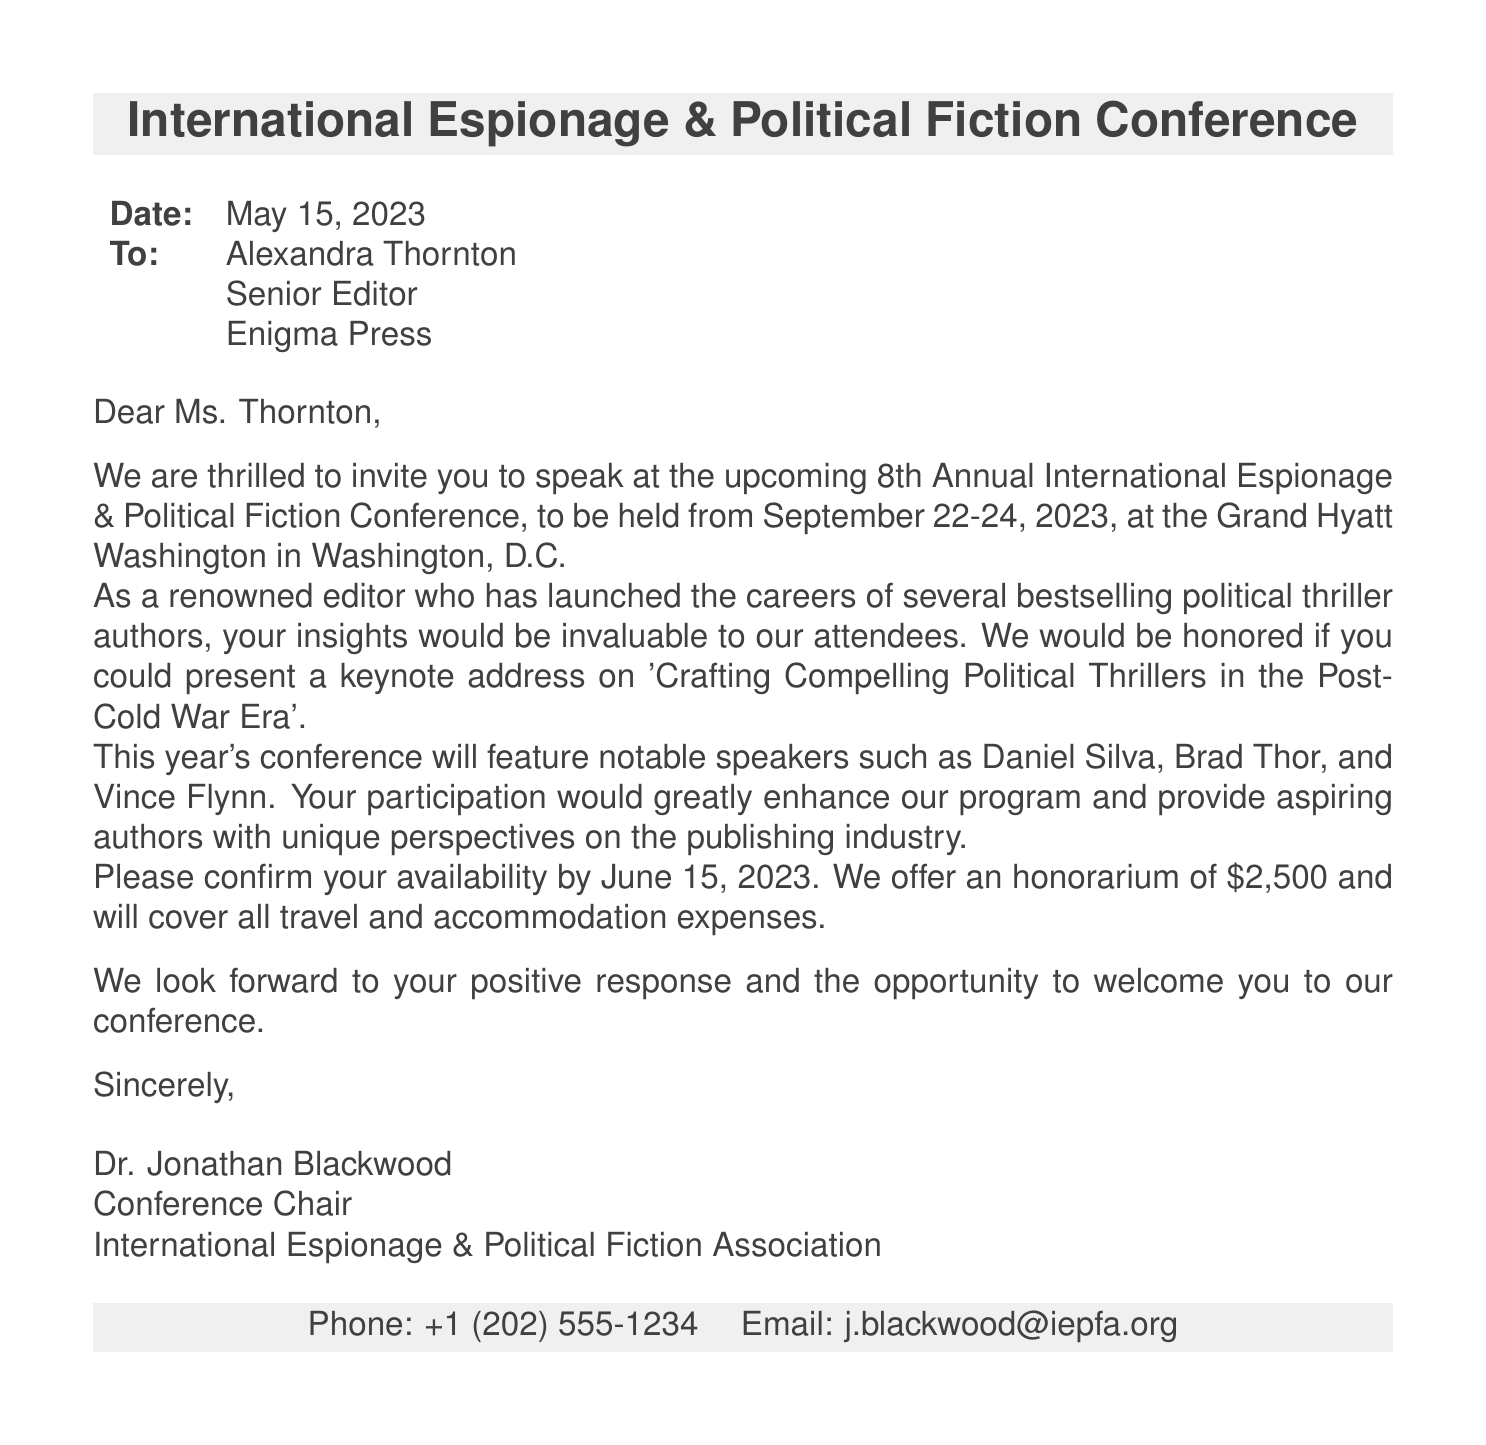What is the date of the conference? The date of the conference is mentioned explicitly in the document as September 22-24, 2023.
Answer: September 22-24, 2023 Who is the recipient of the invitation? The document specifies that the invitation is addressed to Alexandra Thornton.
Answer: Alexandra Thornton What is the theme of the keynote address? The specific theme for the keynote address is detailed as 'Crafting Compelling Political Thrillers in the Post-Cold War Era'.
Answer: Crafting Compelling Political Thrillers in the Post-Cold War Era Who are some of the notable speakers mentioned? The document lists notable speakers for the conference including Daniel Silva, Brad Thor, and Vince Flynn.
Answer: Daniel Silva, Brad Thor, and Vince Flynn What is the honorarium amount offered? The document states that the offered honorarium for speaking at the conference is $2,500.
Answer: $2,500 What is the last date to confirm availability? The document indicates that the recipient should confirm availability by June 15, 2023.
Answer: June 15, 2023 Where is the conference location? The document specifies that the conference will be held at the Grand Hyatt Washington in Washington, D.C.
Answer: Grand Hyatt Washington, Washington, D.C What expenses will be covered for the speaker? The document mentions that all travel and accommodation expenses will be covered.
Answer: Travel and accommodation expenses 